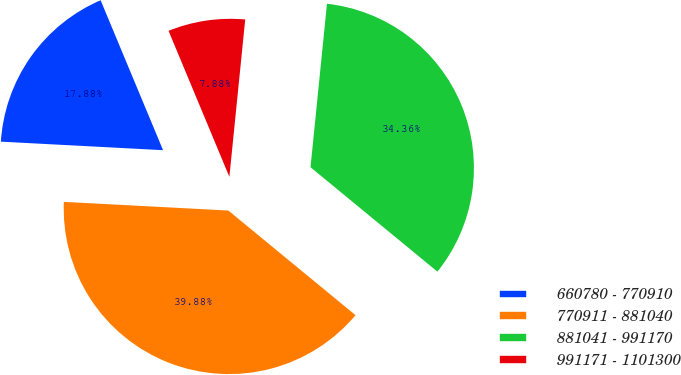<chart> <loc_0><loc_0><loc_500><loc_500><pie_chart><fcel>660780 - 770910<fcel>770911 - 881040<fcel>881041 - 991170<fcel>991171 - 1101300<nl><fcel>17.88%<fcel>39.88%<fcel>34.36%<fcel>7.88%<nl></chart> 